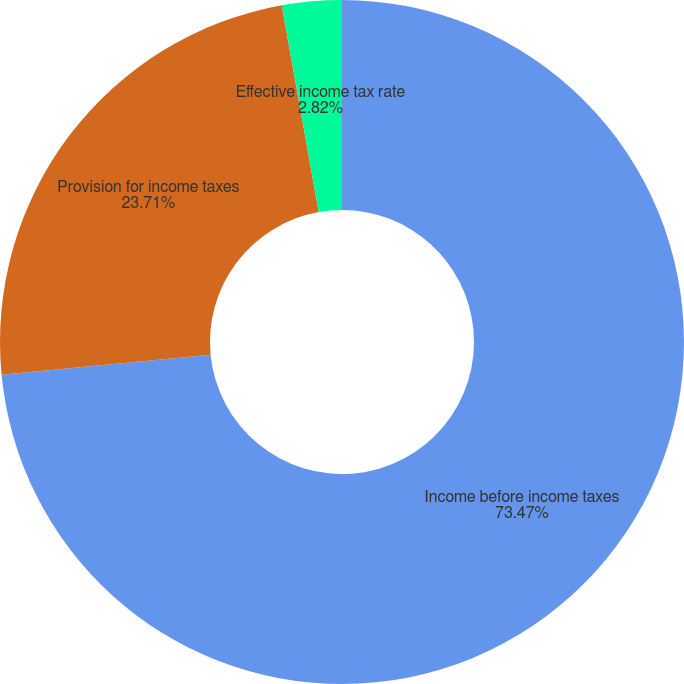Convert chart to OTSL. <chart><loc_0><loc_0><loc_500><loc_500><pie_chart><fcel>Income before income taxes<fcel>Provision for income taxes<fcel>Effective income tax rate<nl><fcel>73.47%<fcel>23.71%<fcel>2.82%<nl></chart> 